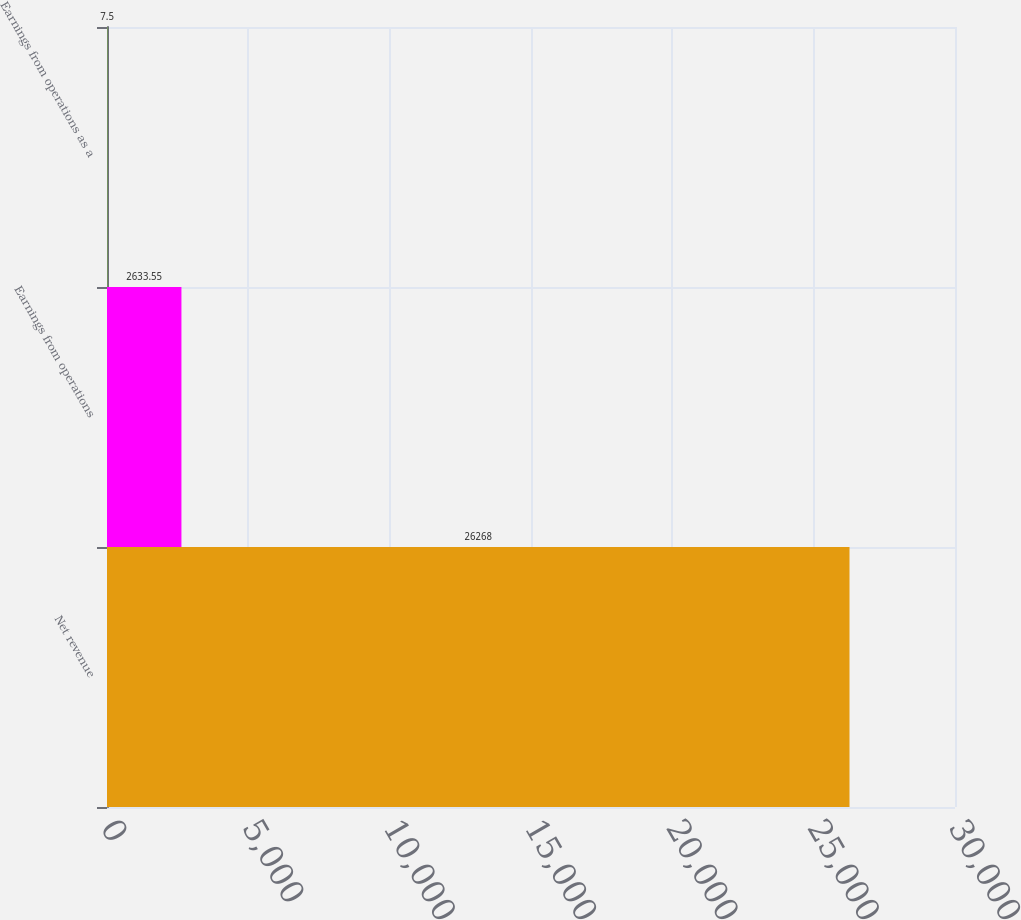Convert chart. <chart><loc_0><loc_0><loc_500><loc_500><bar_chart><fcel>Net revenue<fcel>Earnings from operations<fcel>Earnings from operations as a<nl><fcel>26268<fcel>2633.55<fcel>7.5<nl></chart> 